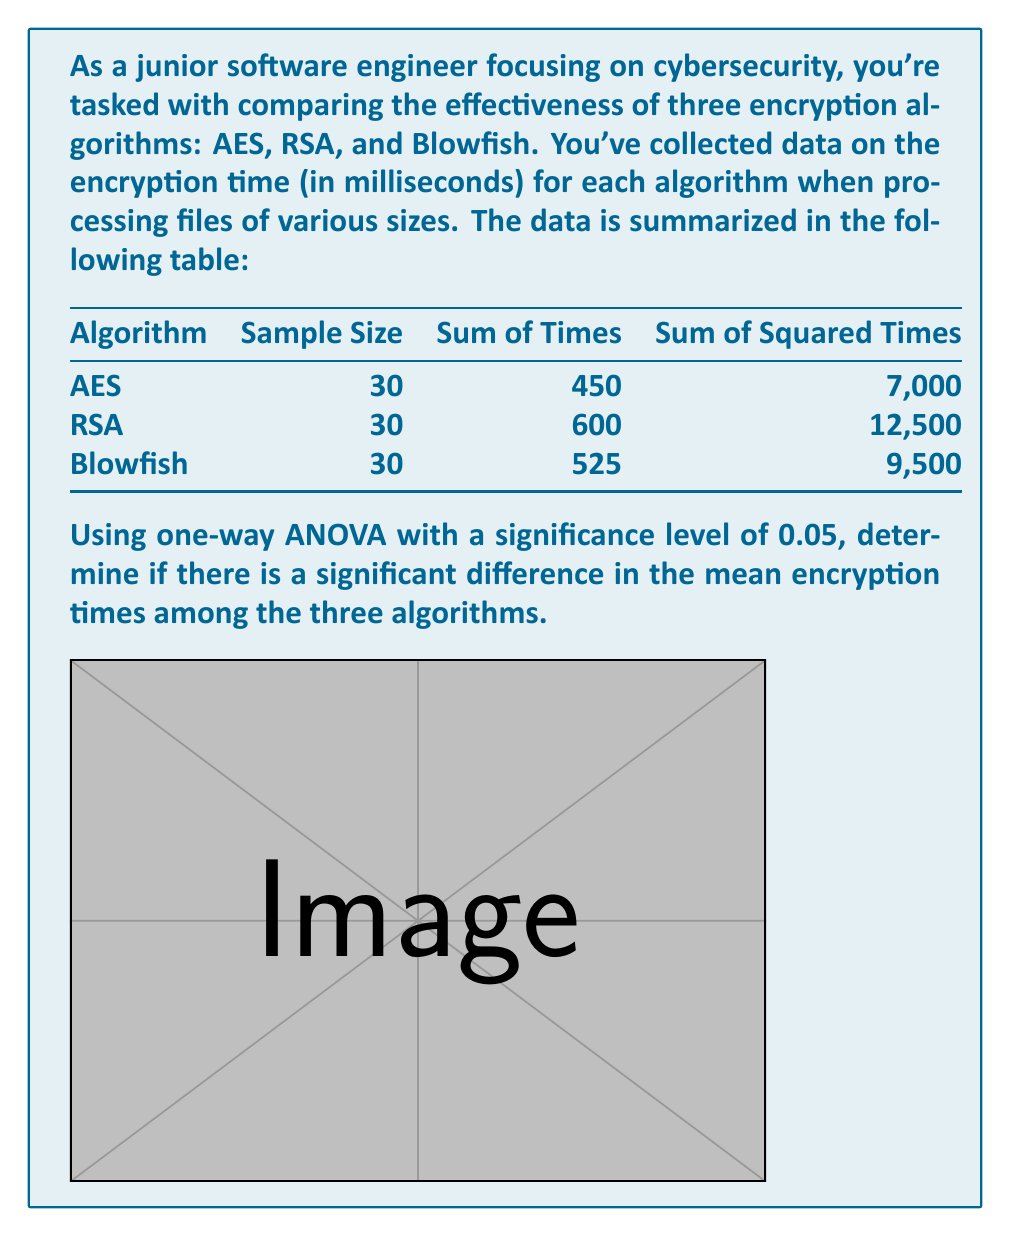Provide a solution to this math problem. Let's solve this problem step by step using one-way ANOVA:

1) First, calculate the total sum of squares (SST):
   $$SST = \sum_{i=1}^{3} \sum_{j=1}^{30} x_{ij}^2 - \frac{(\sum_{i=1}^{3} \sum_{j=1}^{30} x_{ij})^2}{N}$$
   $$SST = (7000 + 12500 + 9500) - \frac{(450 + 600 + 525)^2}{90} = 29000 - \frac{1575^2}{90} = 1775$$

2) Calculate the sum of squares between groups (SSB):
   $$SSB = \sum_{i=1}^{3} \frac{(\sum_{j=1}^{30} x_{ij})^2}{n_i} - \frac{(\sum_{i=1}^{3} \sum_{j=1}^{30} x_{ij})^2}{N}$$
   $$SSB = \frac{450^2 + 600^2 + 525^2}{30} - \frac{1575^2}{90} = 1625$$

3) Calculate the sum of squares within groups (SSW):
   $$SSW = SST - SSB = 1775 - 1625 = 150$$

4) Degrees of freedom:
   Between groups: $df_B = k - 1 = 3 - 1 = 2$
   Within groups: $df_W = N - k = 90 - 3 = 87$
   Total: $df_T = N - 1 = 90 - 1 = 89$

5) Mean squares:
   $$MS_B = \frac{SSB}{df_B} = \frac{1625}{2} = 812.5$$
   $$MS_W = \frac{SSW}{df_W} = \frac{150}{87} \approx 1.72$$

6) F-statistic:
   $$F = \frac{MS_B}{MS_W} = \frac{812.5}{1.72} \approx 472.09$$

7) The critical F-value for $\alpha = 0.05$, $df_B = 2$, and $df_W = 87$ is approximately 3.10.

8) Since our calculated F-value (472.09) is greater than the critical F-value (3.10), we reject the null hypothesis.
Answer: There is a significant difference in mean encryption times (F(2,87) = 472.09, p < 0.05). 